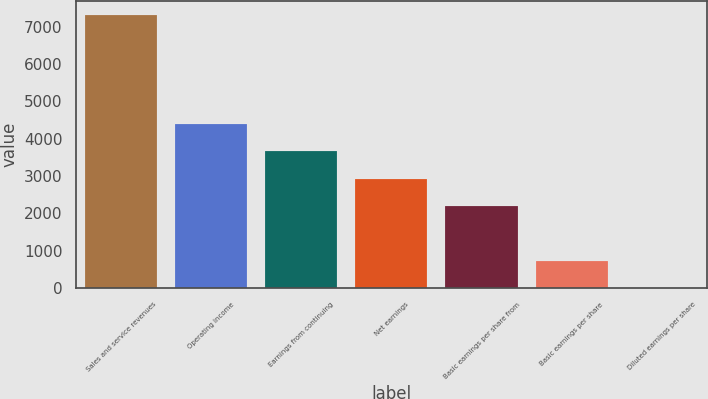Convert chart to OTSL. <chart><loc_0><loc_0><loc_500><loc_500><bar_chart><fcel>Sales and service revenues<fcel>Operating income<fcel>Earnings from continuing<fcel>Net earnings<fcel>Basic earnings per share from<fcel>Basic earnings per share<fcel>Diluted earnings per share<nl><fcel>7314<fcel>4388.84<fcel>3657.55<fcel>2926.26<fcel>2194.97<fcel>732.39<fcel>1.1<nl></chart> 